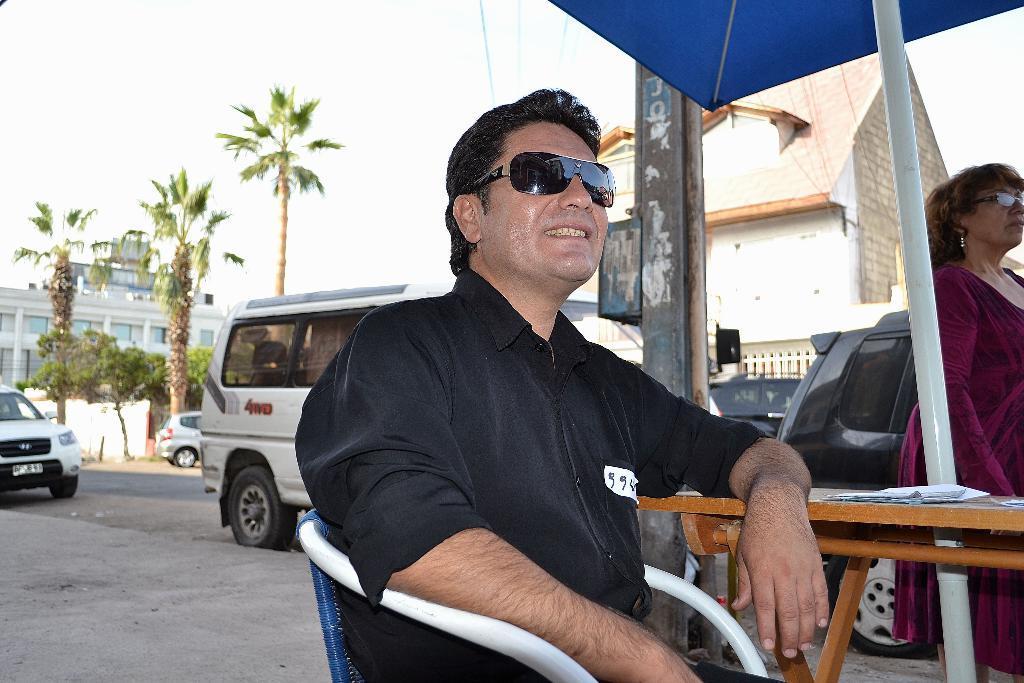Can you describe this image briefly? There is a man sitting in the foreground, there is a lady, papers on a table and an umbrella on the right side. There are vehicles, trees, houses, wires, pole and sky in the background area. 